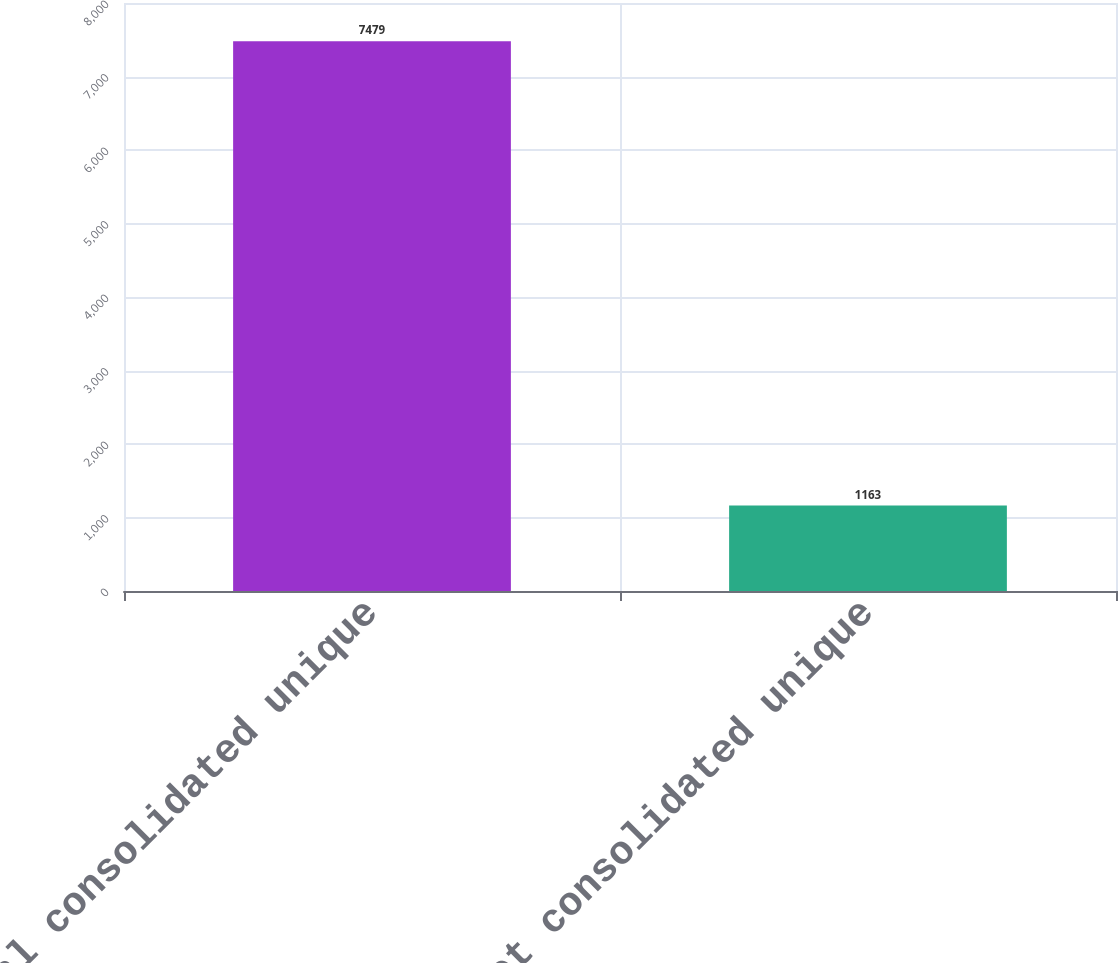<chart> <loc_0><loc_0><loc_500><loc_500><bar_chart><fcel>Total consolidated unique<fcel>Net consolidated unique<nl><fcel>7479<fcel>1163<nl></chart> 